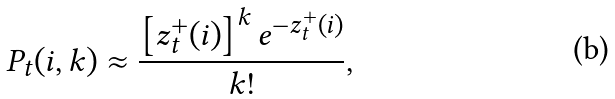Convert formula to latex. <formula><loc_0><loc_0><loc_500><loc_500>P _ { t } ( i , k ) \approx \frac { \left [ z _ { t } ^ { + } ( i ) \right ] ^ { k } e ^ { - z _ { t } ^ { + } ( i ) } } { k ! } ,</formula> 